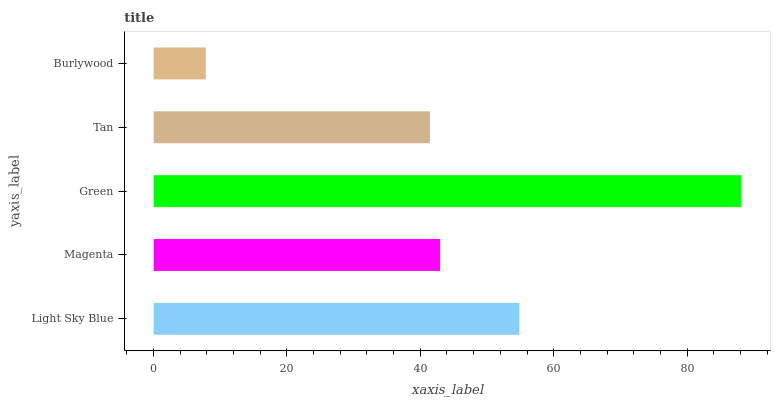Is Burlywood the minimum?
Answer yes or no. Yes. Is Green the maximum?
Answer yes or no. Yes. Is Magenta the minimum?
Answer yes or no. No. Is Magenta the maximum?
Answer yes or no. No. Is Light Sky Blue greater than Magenta?
Answer yes or no. Yes. Is Magenta less than Light Sky Blue?
Answer yes or no. Yes. Is Magenta greater than Light Sky Blue?
Answer yes or no. No. Is Light Sky Blue less than Magenta?
Answer yes or no. No. Is Magenta the high median?
Answer yes or no. Yes. Is Magenta the low median?
Answer yes or no. Yes. Is Green the high median?
Answer yes or no. No. Is Burlywood the low median?
Answer yes or no. No. 